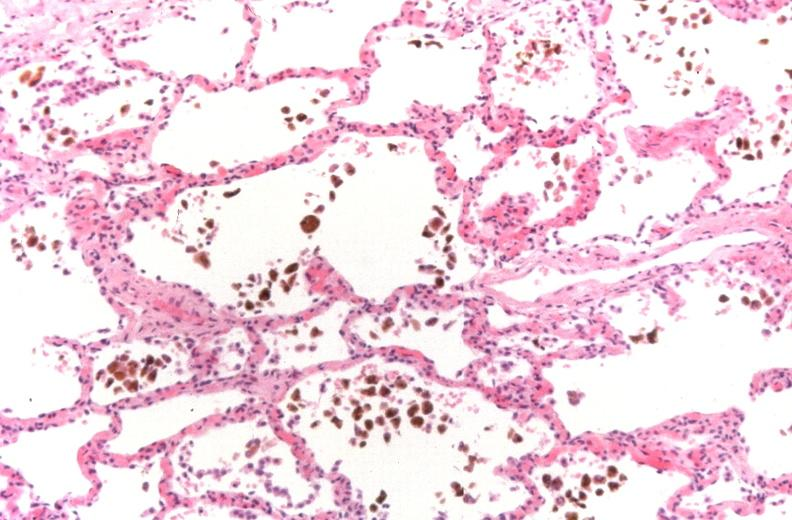what is present?
Answer the question using a single word or phrase. Respiratory 